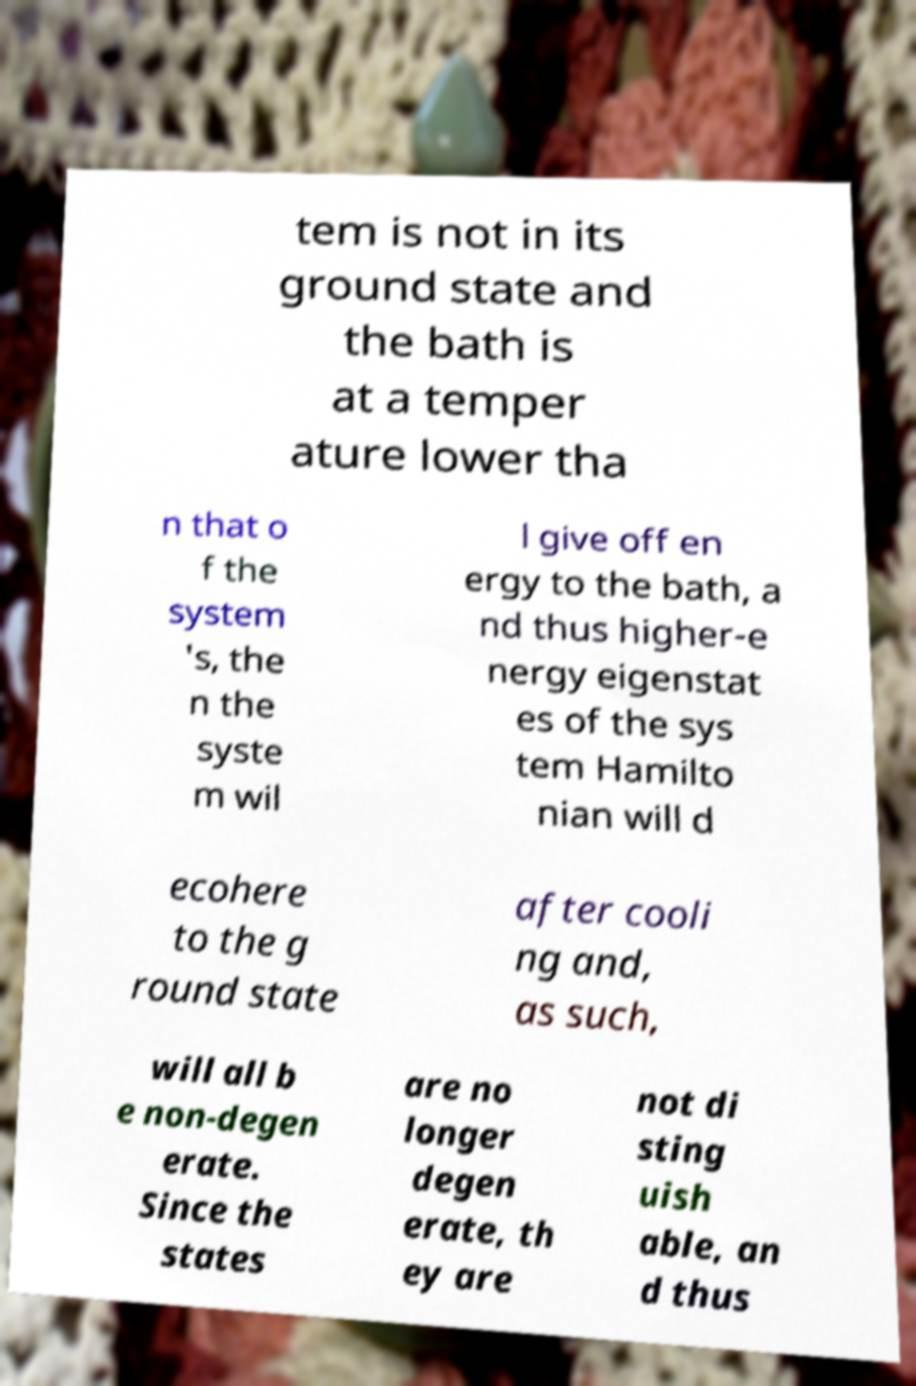There's text embedded in this image that I need extracted. Can you transcribe it verbatim? tem is not in its ground state and the bath is at a temper ature lower tha n that o f the system 's, the n the syste m wil l give off en ergy to the bath, a nd thus higher-e nergy eigenstat es of the sys tem Hamilto nian will d ecohere to the g round state after cooli ng and, as such, will all b e non-degen erate. Since the states are no longer degen erate, th ey are not di sting uish able, an d thus 